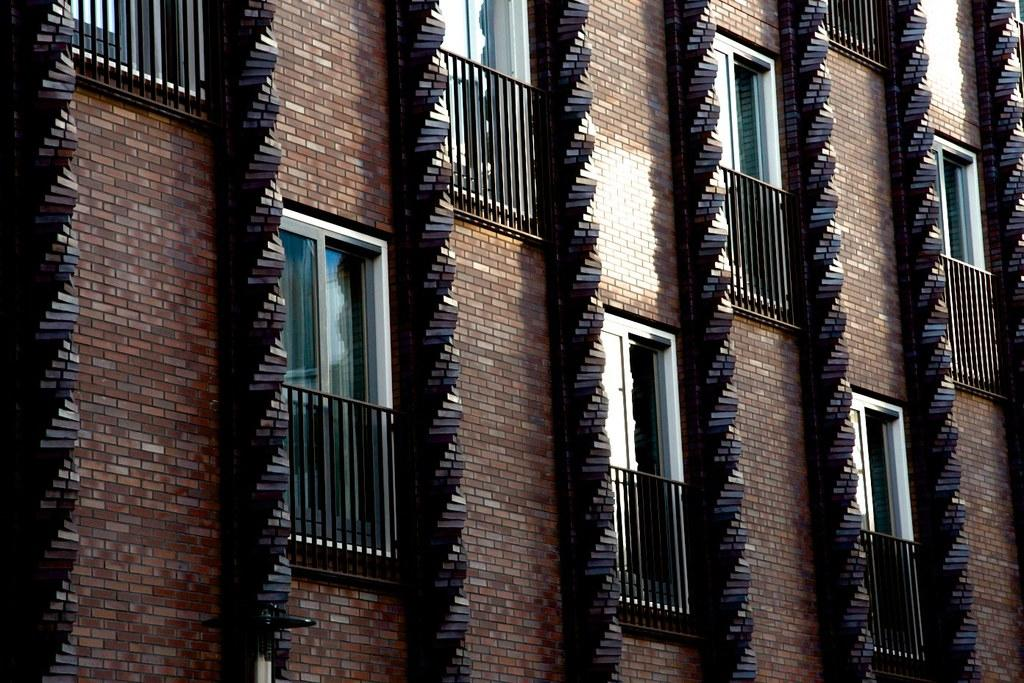What is a prominent feature in the image? There is a wall in the image. What can be seen on the wall? The wall has windows. What additional detail can be observed about the windows? The windows have grilles. What type of tray is being used to cause a mine to explode in the image? There is no tray or mine present in the image; it only features a wall with windows and grilles. 